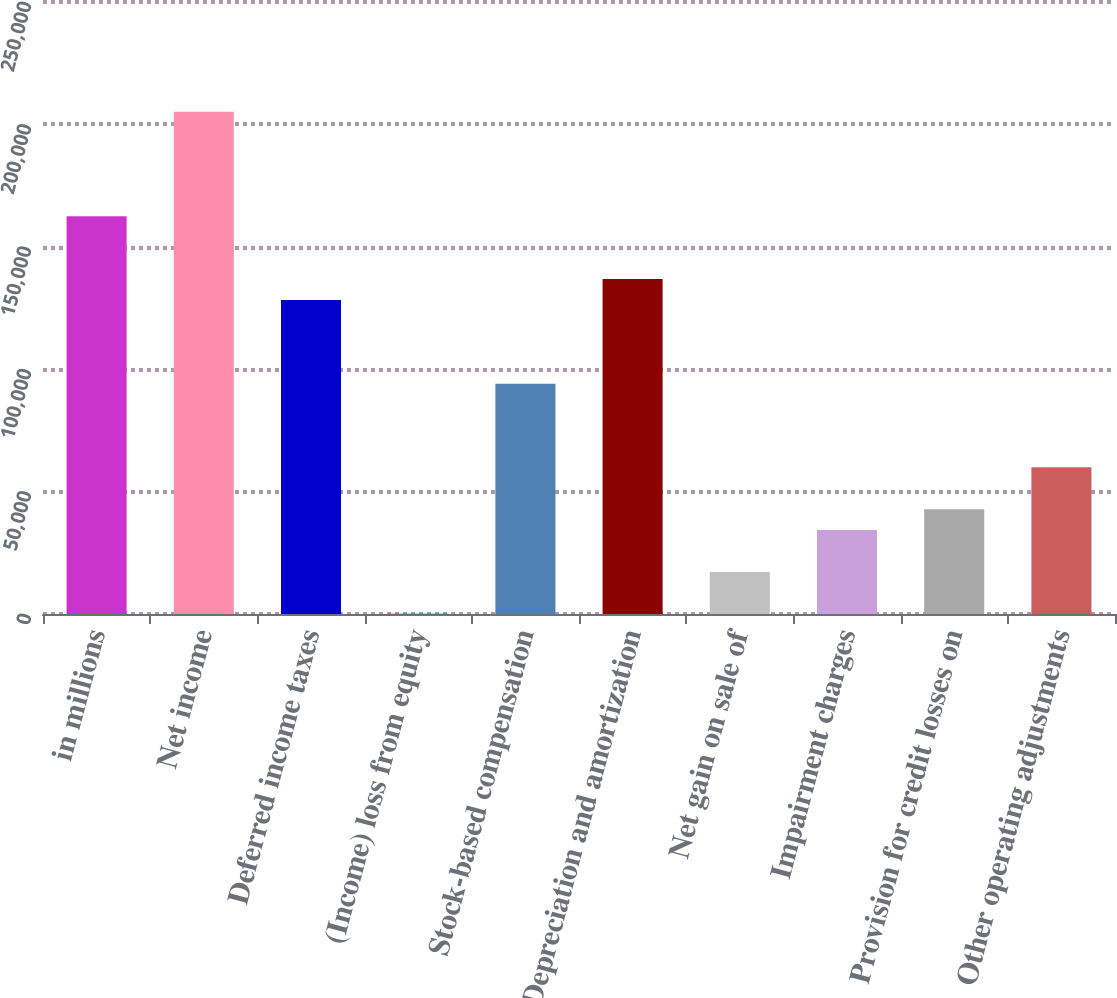Convert chart. <chart><loc_0><loc_0><loc_500><loc_500><bar_chart><fcel>in millions<fcel>Net income<fcel>Deferred income taxes<fcel>(Income) loss from equity<fcel>Stock-based compensation<fcel>Depreciation and amortization<fcel>Net gain on sale of<fcel>Impairment charges<fcel>Provision for credit losses on<fcel>Other operating adjustments<nl><fcel>162478<fcel>205214<fcel>128288<fcel>79<fcel>94099.3<fcel>136836<fcel>17173.6<fcel>34268.2<fcel>42815.5<fcel>59910.1<nl></chart> 